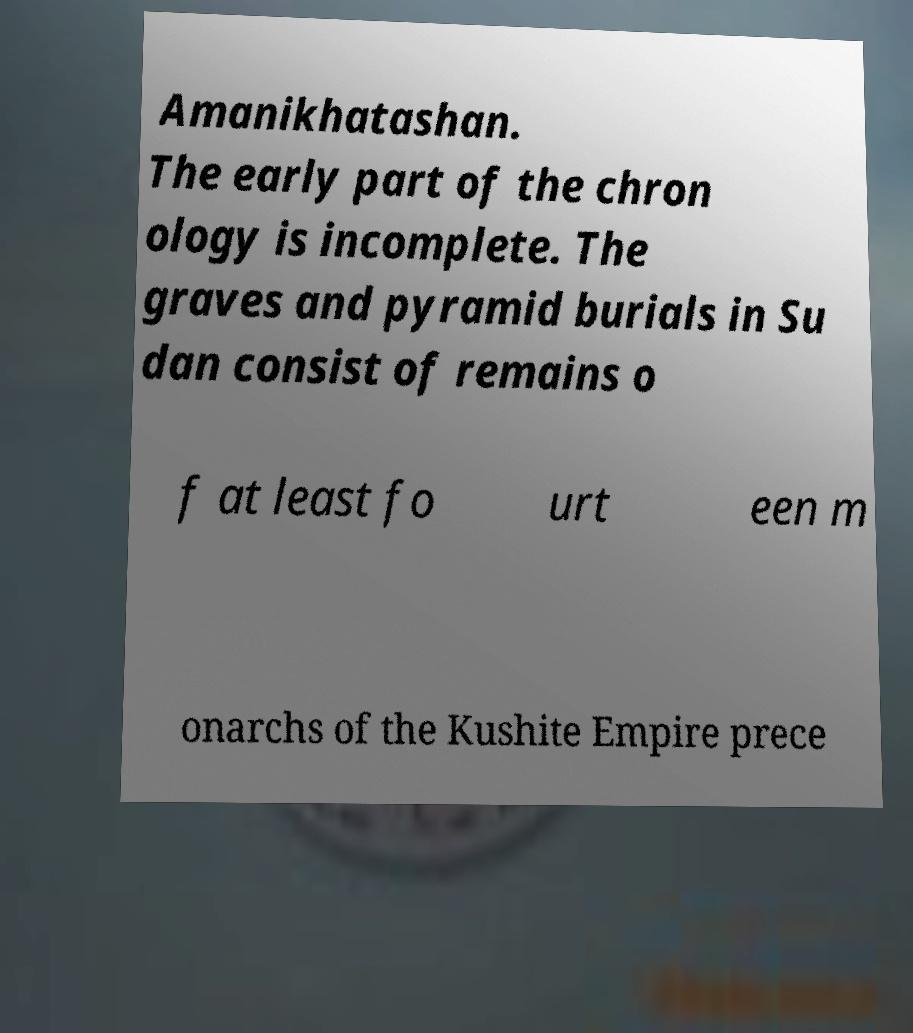Can you accurately transcribe the text from the provided image for me? Amanikhatashan. The early part of the chron ology is incomplete. The graves and pyramid burials in Su dan consist of remains o f at least fo urt een m onarchs of the Kushite Empire prece 